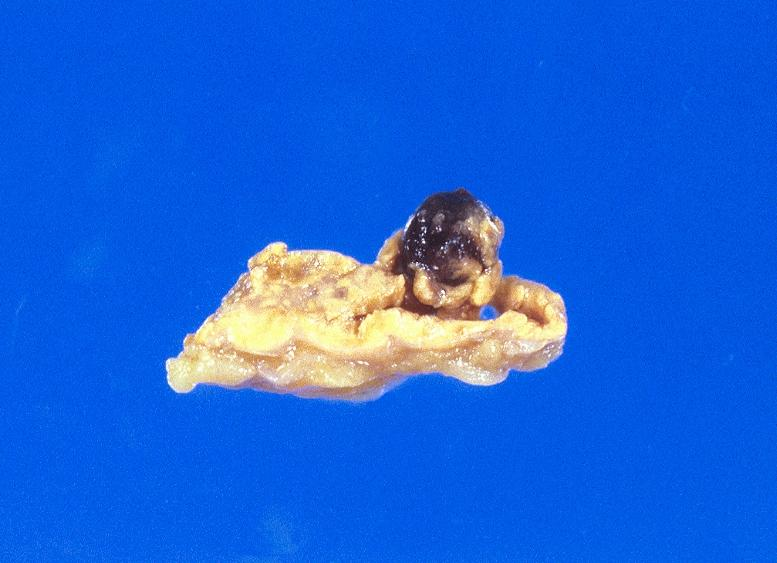does this image show malignant melanoma?
Answer the question using a single word or phrase. Yes 